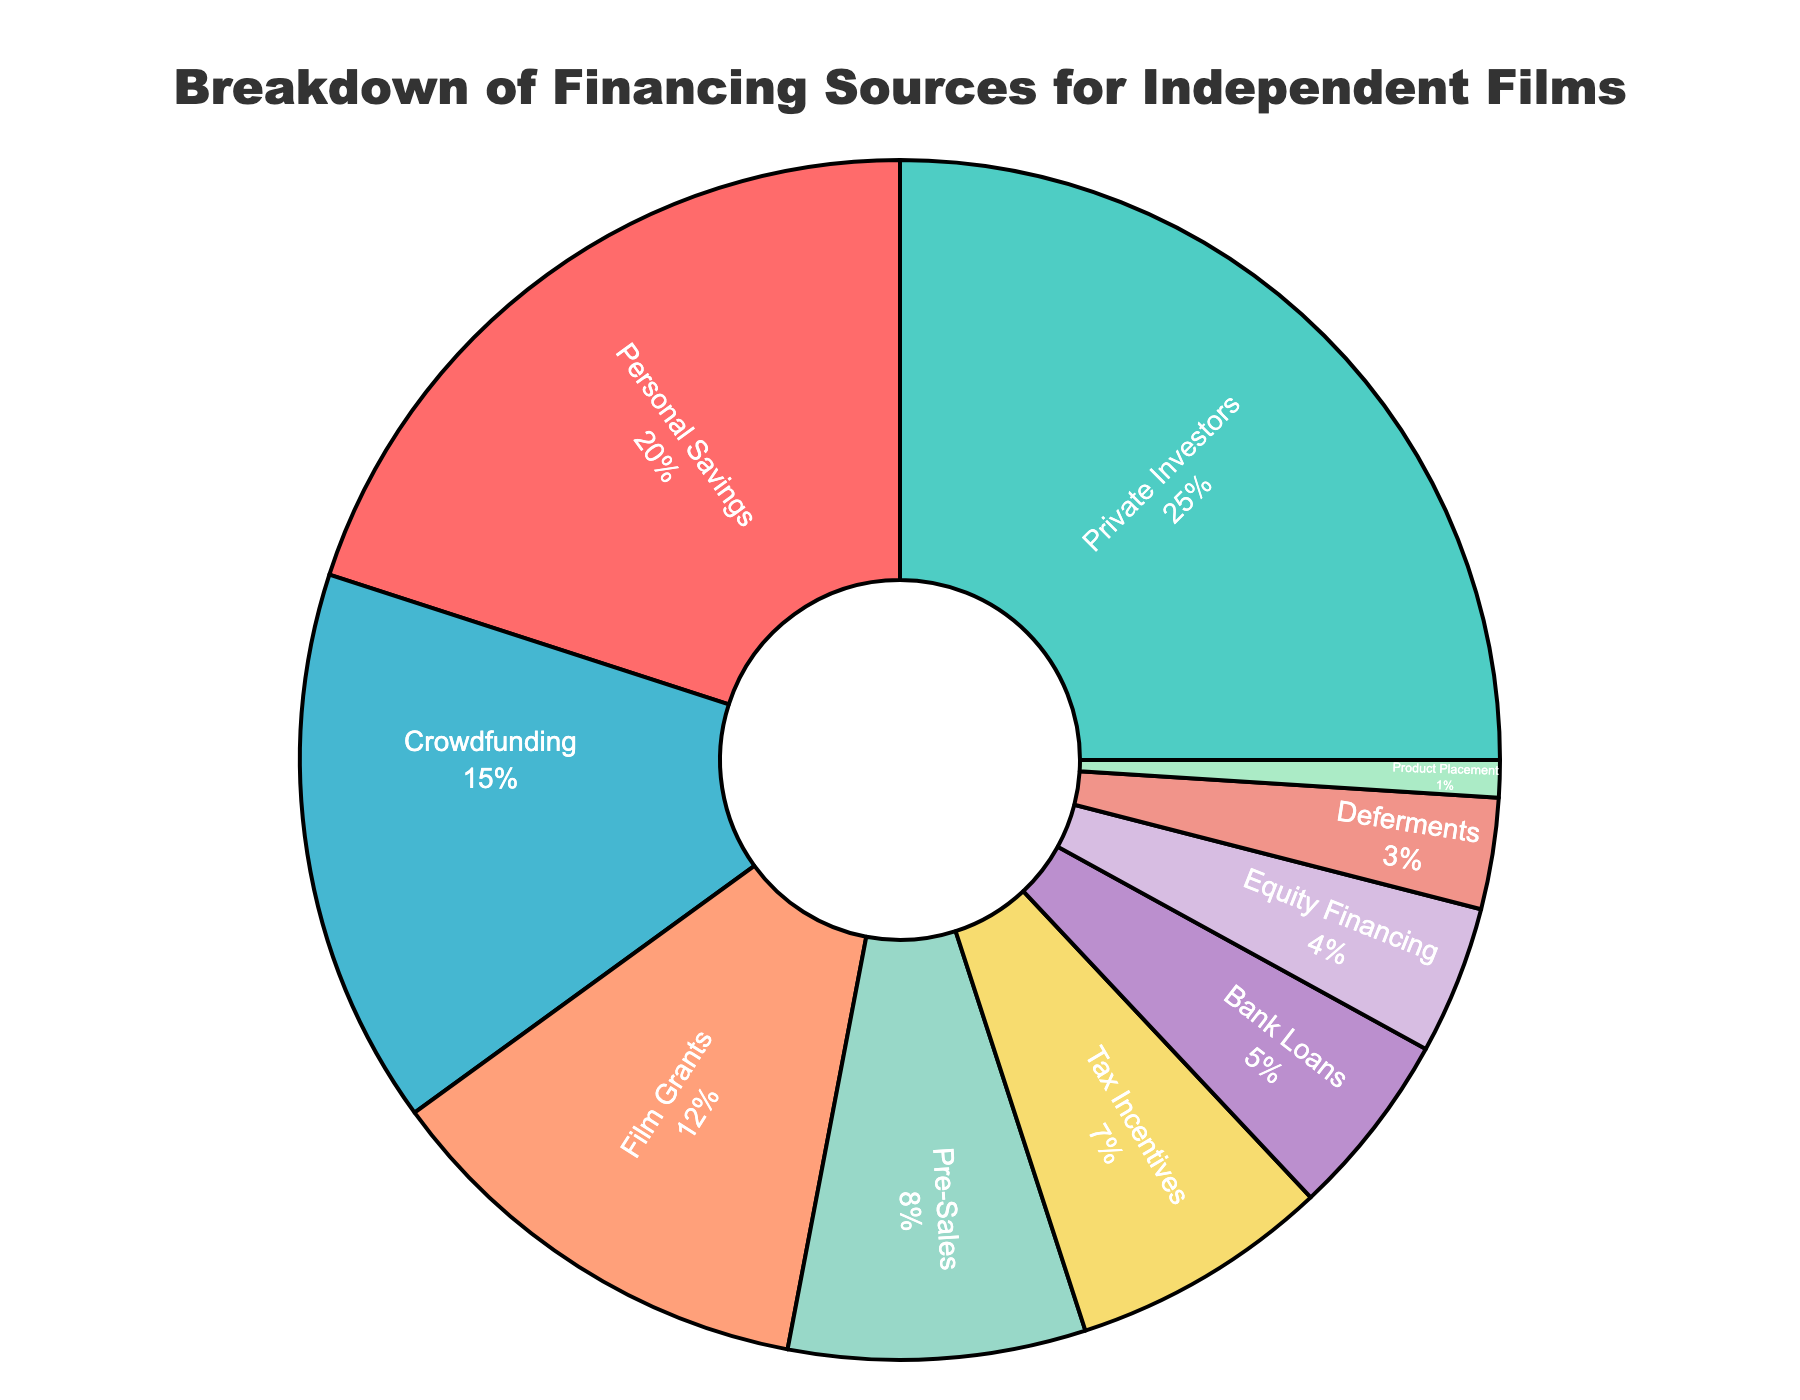Which funding source contributes the highest percentage to independent film financing? The pie chart shows different funding sources with their percentages. The largest section corresponds to Private Investors with 25%.
Answer: Private Investors What is the combined percentage of funding from Personal Savings and Crowdfunding? Referring to the pie chart, Personal Savings contribute 20% and Crowdfunding contributes 15%. Summing these up, 20% + 15% = 35%.
Answer: 35% Which funding source provides more financing: Film Grants or Tax Incentives? By observing the pie chart, Film Grants provide 12% while Tax Incentives provide 7%. Since 12% is greater than 7%, Film Grants provide more financing.
Answer: Film Grants What is the total percentage contributed by Pre-Sales, Bank Loans, and Equity Financing? The pie chart indicates Pre-Sales at 8%, Bank Loans at 5%, and Equity Financing at 4%. Summing these up, 8% + 5% + 4% = 17%.
Answer: 17% Are there any funding sources that provide an equal percentage of financing? Each section of the pie chart shows different percentages for all funding sources with no two sections sharing the same percentage.
Answer: No What is the ratio of Private Investors’ contribution to that of Deferments? The pie chart indicates Private Investors contribute 25% while Deferments contribute 3%. The ratio calculated is 25/3.
Answer: 25:3 Which funding source is represented by the smallest segment in the pie chart, and what is its percentage? The smallest segment in the pie chart corresponds to Product Placement, contributing 1%.
Answer: Product Placement, 1% What proportion of the total funding is provided by sources other than Personal Savings, Private Investors, and Crowdfunding? Excluding Personal Savings (20%), Private Investors (25%), and Crowdfunding (15%), the remaining sources sum up to 12% (Film Grants) + 8% (Pre-Sales) + 7% (Tax Incentives) + 5% (Bank Loans) + 4% (Equity Financing) + 3% (Deferments) + 1% (Product Placement) = 40%.
Answer: 40% By how much does the sum of financing from Tax Incentives and Equity Financing exceed that from Deferments and Product Placement combined? Tax Incentives contribute 7% and Equity Financing contributes 4%, totaling 11%. Deferments contribute 3% and Product Placement contributes 1%, totaling 4%. The excess amount is 11% - 4% = 7%.
Answer: 7% Considering all the sources, what is the average percentage contribution to film financing? There are 10 funding sources with total contributions summing up to 100%. The average contribution is calculated as 100% / 10 = 10%.
Answer: 10% 